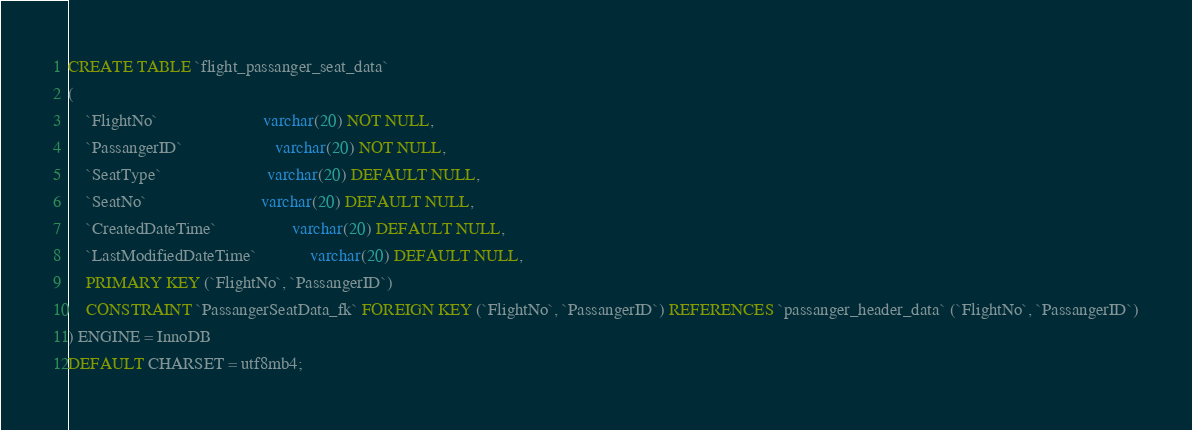Convert code to text. <code><loc_0><loc_0><loc_500><loc_500><_SQL_>CREATE TABLE `flight_passanger_seat_data`
(
    `FlightNo`                        varchar(20) NOT NULL,
    `PassangerID`                     varchar(20) NOT NULL,
    `SeatType`                        varchar(20) DEFAULT NULL, 
    `SeatNo`                          varchar(20) DEFAULT NULL, 
    `CreatedDateTime`                 varchar(20) DEFAULT NULL,
    `LastModifiedDateTime`            varchar(20) DEFAULT NULL,
    PRIMARY KEY (`FlightNo`, `PassangerID`)
    CONSTRAINT `PassangerSeatData_fk` FOREIGN KEY (`FlightNo`, `PassangerID`) REFERENCES `passanger_header_data` (`FlightNo`, `PassangerID`)
) ENGINE = InnoDB
DEFAULT CHARSET = utf8mb4;</code> 